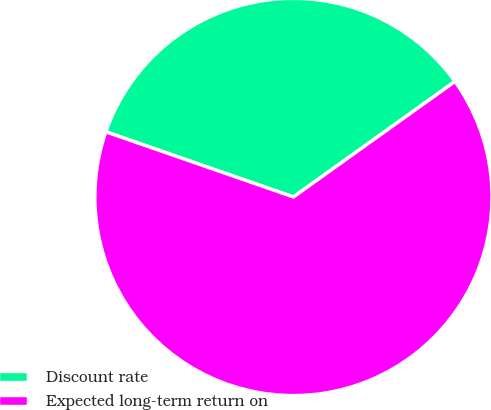<chart> <loc_0><loc_0><loc_500><loc_500><pie_chart><fcel>Discount rate<fcel>Expected long-term return on<nl><fcel>34.8%<fcel>65.2%<nl></chart> 